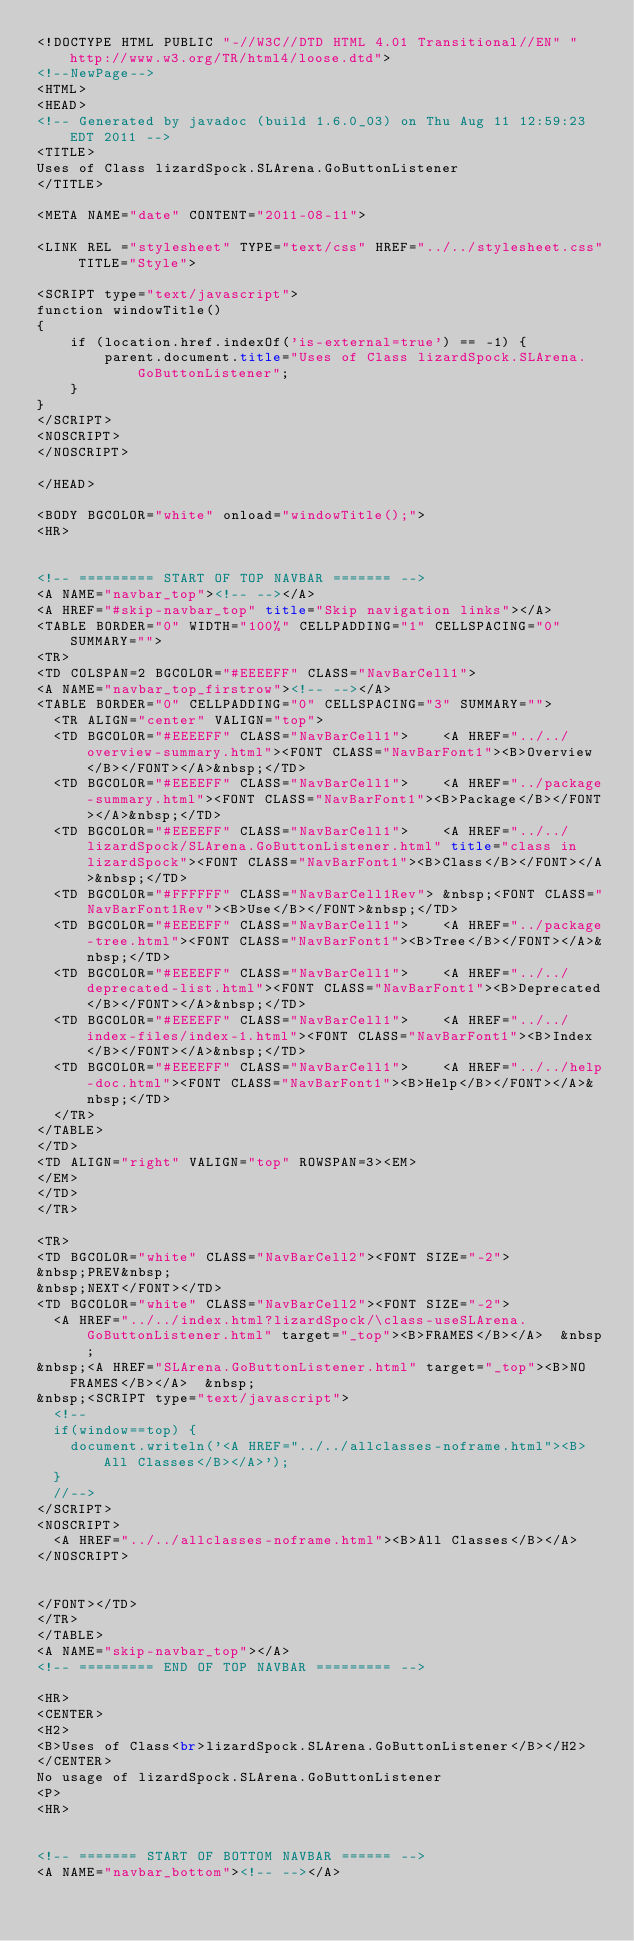<code> <loc_0><loc_0><loc_500><loc_500><_HTML_><!DOCTYPE HTML PUBLIC "-//W3C//DTD HTML 4.01 Transitional//EN" "http://www.w3.org/TR/html4/loose.dtd">
<!--NewPage-->
<HTML>
<HEAD>
<!-- Generated by javadoc (build 1.6.0_03) on Thu Aug 11 12:59:23 EDT 2011 -->
<TITLE>
Uses of Class lizardSpock.SLArena.GoButtonListener
</TITLE>

<META NAME="date" CONTENT="2011-08-11">

<LINK REL ="stylesheet" TYPE="text/css" HREF="../../stylesheet.css" TITLE="Style">

<SCRIPT type="text/javascript">
function windowTitle()
{
    if (location.href.indexOf('is-external=true') == -1) {
        parent.document.title="Uses of Class lizardSpock.SLArena.GoButtonListener";
    }
}
</SCRIPT>
<NOSCRIPT>
</NOSCRIPT>

</HEAD>

<BODY BGCOLOR="white" onload="windowTitle();">
<HR>


<!-- ========= START OF TOP NAVBAR ======= -->
<A NAME="navbar_top"><!-- --></A>
<A HREF="#skip-navbar_top" title="Skip navigation links"></A>
<TABLE BORDER="0" WIDTH="100%" CELLPADDING="1" CELLSPACING="0" SUMMARY="">
<TR>
<TD COLSPAN=2 BGCOLOR="#EEEEFF" CLASS="NavBarCell1">
<A NAME="navbar_top_firstrow"><!-- --></A>
<TABLE BORDER="0" CELLPADDING="0" CELLSPACING="3" SUMMARY="">
  <TR ALIGN="center" VALIGN="top">
  <TD BGCOLOR="#EEEEFF" CLASS="NavBarCell1">    <A HREF="../../overview-summary.html"><FONT CLASS="NavBarFont1"><B>Overview</B></FONT></A>&nbsp;</TD>
  <TD BGCOLOR="#EEEEFF" CLASS="NavBarCell1">    <A HREF="../package-summary.html"><FONT CLASS="NavBarFont1"><B>Package</B></FONT></A>&nbsp;</TD>
  <TD BGCOLOR="#EEEEFF" CLASS="NavBarCell1">    <A HREF="../../lizardSpock/SLArena.GoButtonListener.html" title="class in lizardSpock"><FONT CLASS="NavBarFont1"><B>Class</B></FONT></A>&nbsp;</TD>
  <TD BGCOLOR="#FFFFFF" CLASS="NavBarCell1Rev"> &nbsp;<FONT CLASS="NavBarFont1Rev"><B>Use</B></FONT>&nbsp;</TD>
  <TD BGCOLOR="#EEEEFF" CLASS="NavBarCell1">    <A HREF="../package-tree.html"><FONT CLASS="NavBarFont1"><B>Tree</B></FONT></A>&nbsp;</TD>
  <TD BGCOLOR="#EEEEFF" CLASS="NavBarCell1">    <A HREF="../../deprecated-list.html"><FONT CLASS="NavBarFont1"><B>Deprecated</B></FONT></A>&nbsp;</TD>
  <TD BGCOLOR="#EEEEFF" CLASS="NavBarCell1">    <A HREF="../../index-files/index-1.html"><FONT CLASS="NavBarFont1"><B>Index</B></FONT></A>&nbsp;</TD>
  <TD BGCOLOR="#EEEEFF" CLASS="NavBarCell1">    <A HREF="../../help-doc.html"><FONT CLASS="NavBarFont1"><B>Help</B></FONT></A>&nbsp;</TD>
  </TR>
</TABLE>
</TD>
<TD ALIGN="right" VALIGN="top" ROWSPAN=3><EM>
</EM>
</TD>
</TR>

<TR>
<TD BGCOLOR="white" CLASS="NavBarCell2"><FONT SIZE="-2">
&nbsp;PREV&nbsp;
&nbsp;NEXT</FONT></TD>
<TD BGCOLOR="white" CLASS="NavBarCell2"><FONT SIZE="-2">
  <A HREF="../../index.html?lizardSpock/\class-useSLArena.GoButtonListener.html" target="_top"><B>FRAMES</B></A>  &nbsp;
&nbsp;<A HREF="SLArena.GoButtonListener.html" target="_top"><B>NO FRAMES</B></A>  &nbsp;
&nbsp;<SCRIPT type="text/javascript">
  <!--
  if(window==top) {
    document.writeln('<A HREF="../../allclasses-noframe.html"><B>All Classes</B></A>');
  }
  //-->
</SCRIPT>
<NOSCRIPT>
  <A HREF="../../allclasses-noframe.html"><B>All Classes</B></A>
</NOSCRIPT>


</FONT></TD>
</TR>
</TABLE>
<A NAME="skip-navbar_top"></A>
<!-- ========= END OF TOP NAVBAR ========= -->

<HR>
<CENTER>
<H2>
<B>Uses of Class<br>lizardSpock.SLArena.GoButtonListener</B></H2>
</CENTER>
No usage of lizardSpock.SLArena.GoButtonListener
<P>
<HR>


<!-- ======= START OF BOTTOM NAVBAR ====== -->
<A NAME="navbar_bottom"><!-- --></A></code> 